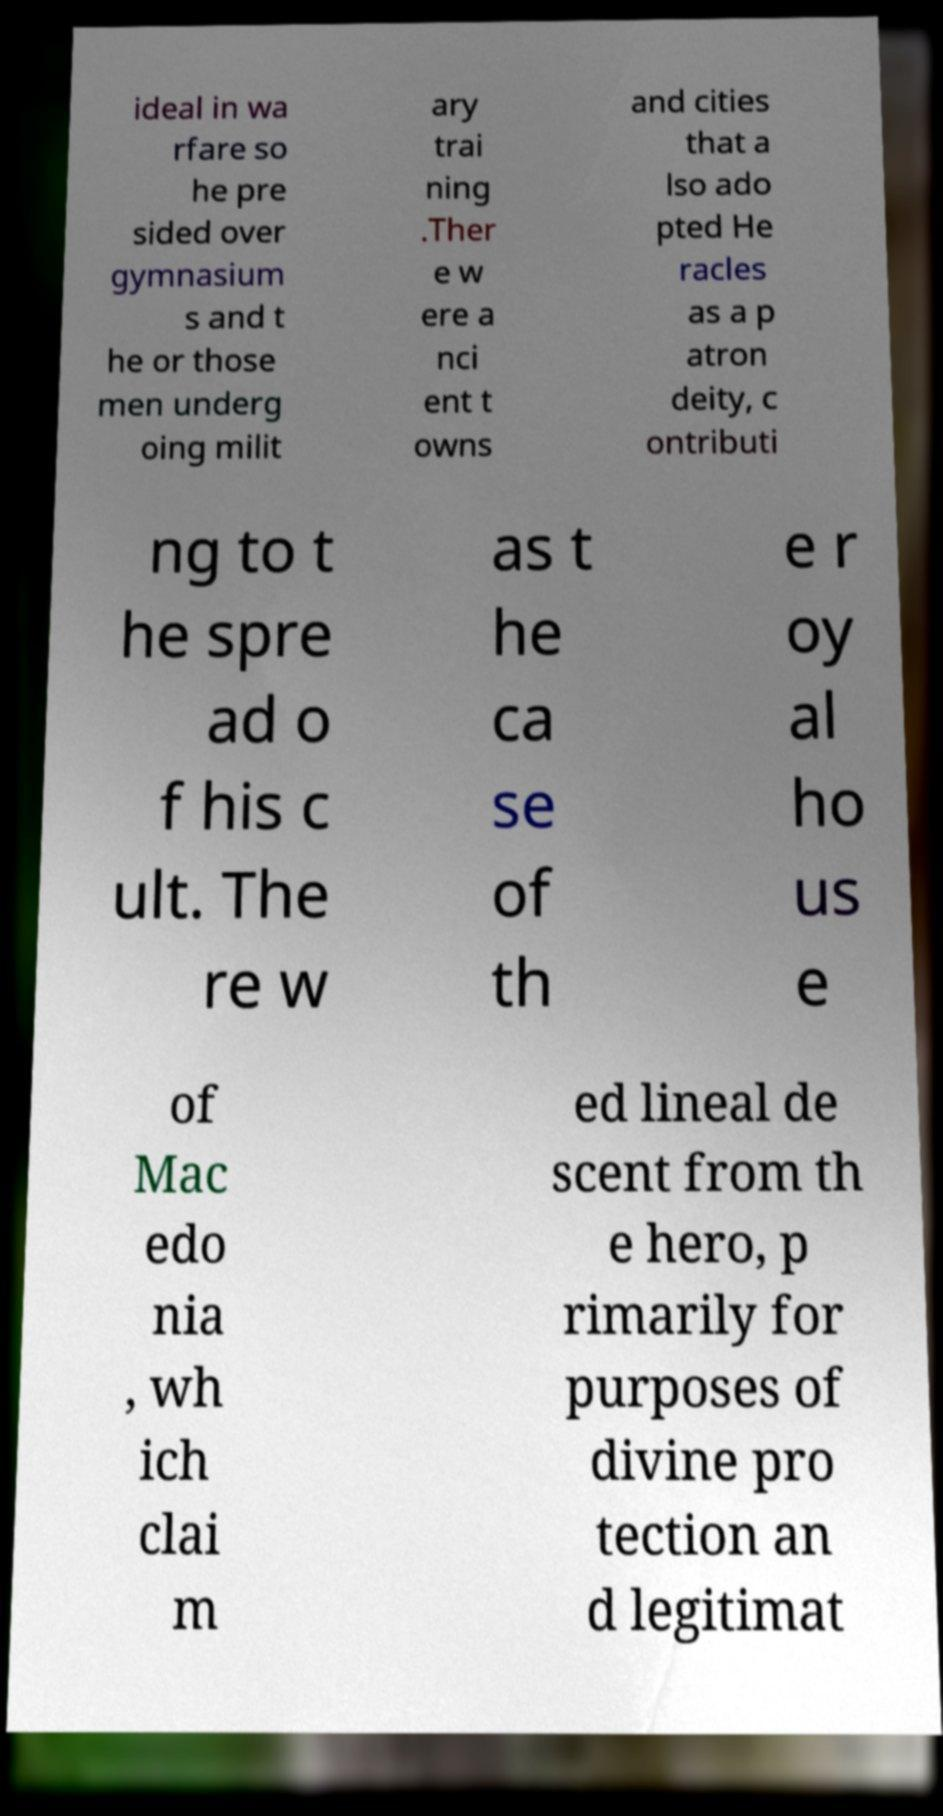Please identify and transcribe the text found in this image. ideal in wa rfare so he pre sided over gymnasium s and t he or those men underg oing milit ary trai ning .Ther e w ere a nci ent t owns and cities that a lso ado pted He racles as a p atron deity, c ontributi ng to t he spre ad o f his c ult. The re w as t he ca se of th e r oy al ho us e of Mac edo nia , wh ich clai m ed lineal de scent from th e hero, p rimarily for purposes of divine pro tection an d legitimat 